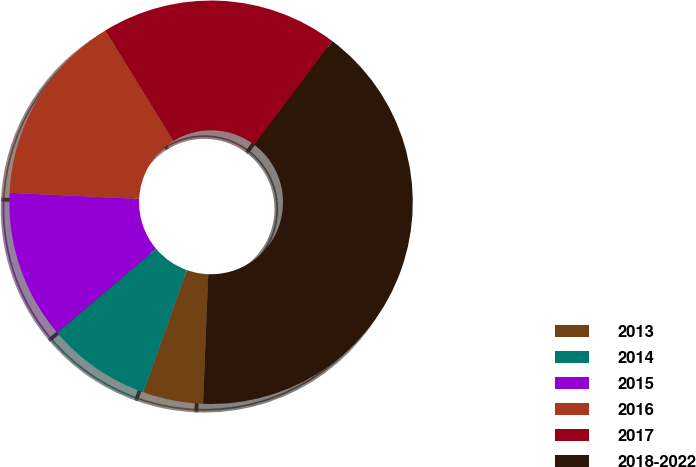Convert chart to OTSL. <chart><loc_0><loc_0><loc_500><loc_500><pie_chart><fcel>2013<fcel>2014<fcel>2015<fcel>2016<fcel>2017<fcel>2018-2022<nl><fcel>4.82%<fcel>8.37%<fcel>11.93%<fcel>15.48%<fcel>19.04%<fcel>40.36%<nl></chart> 